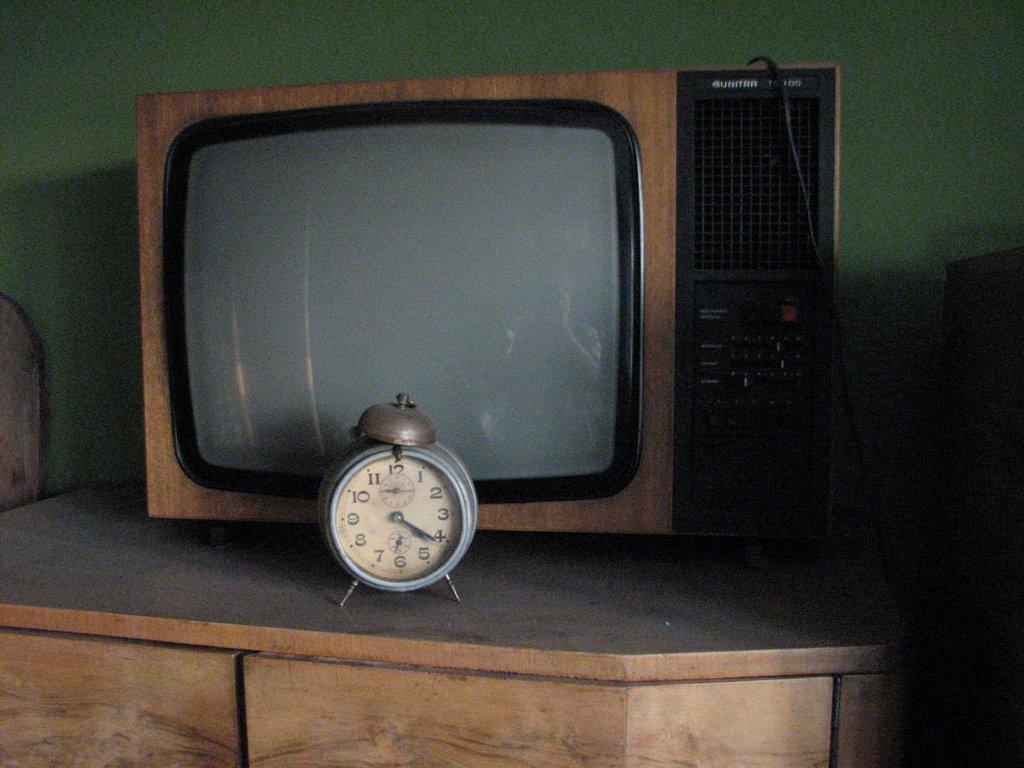What time does the clock say?
Provide a succinct answer. 4:20. 